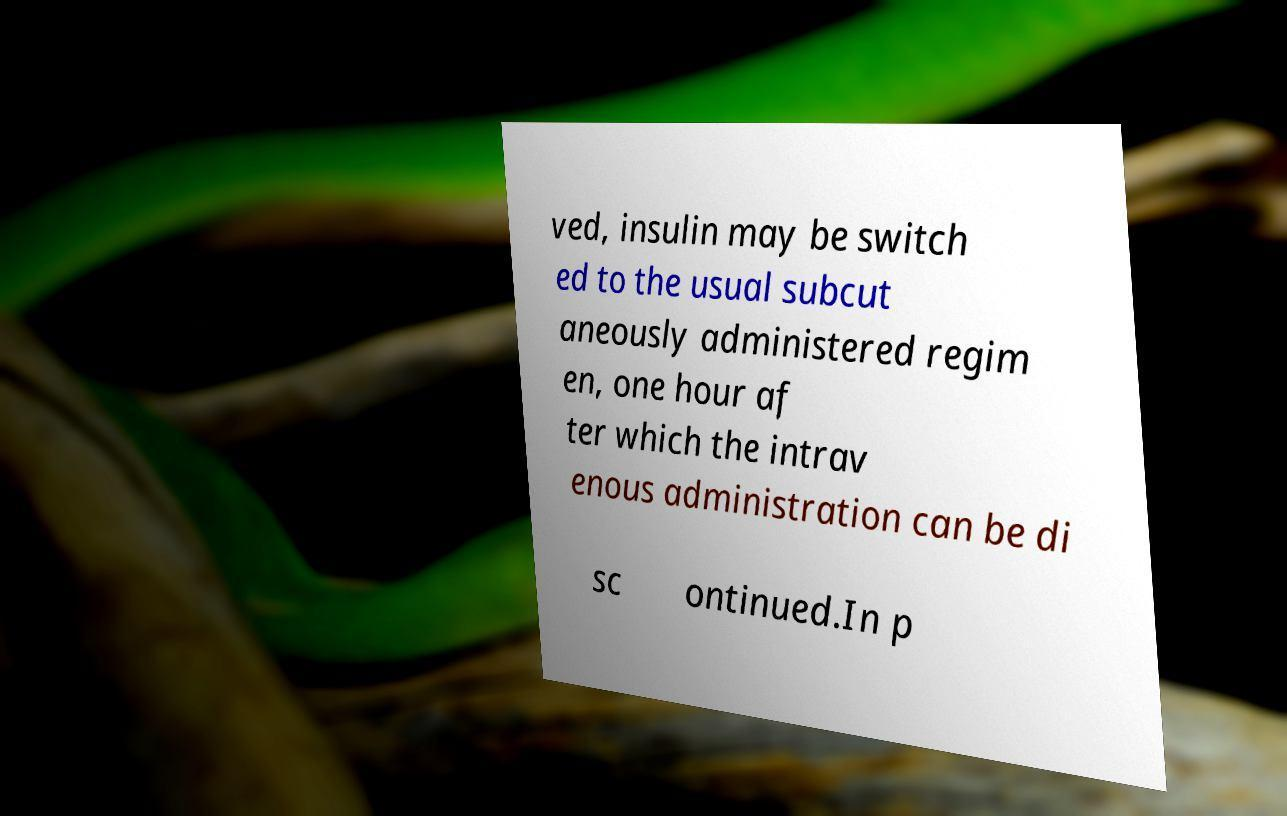For documentation purposes, I need the text within this image transcribed. Could you provide that? ved, insulin may be switch ed to the usual subcut aneously administered regim en, one hour af ter which the intrav enous administration can be di sc ontinued.In p 